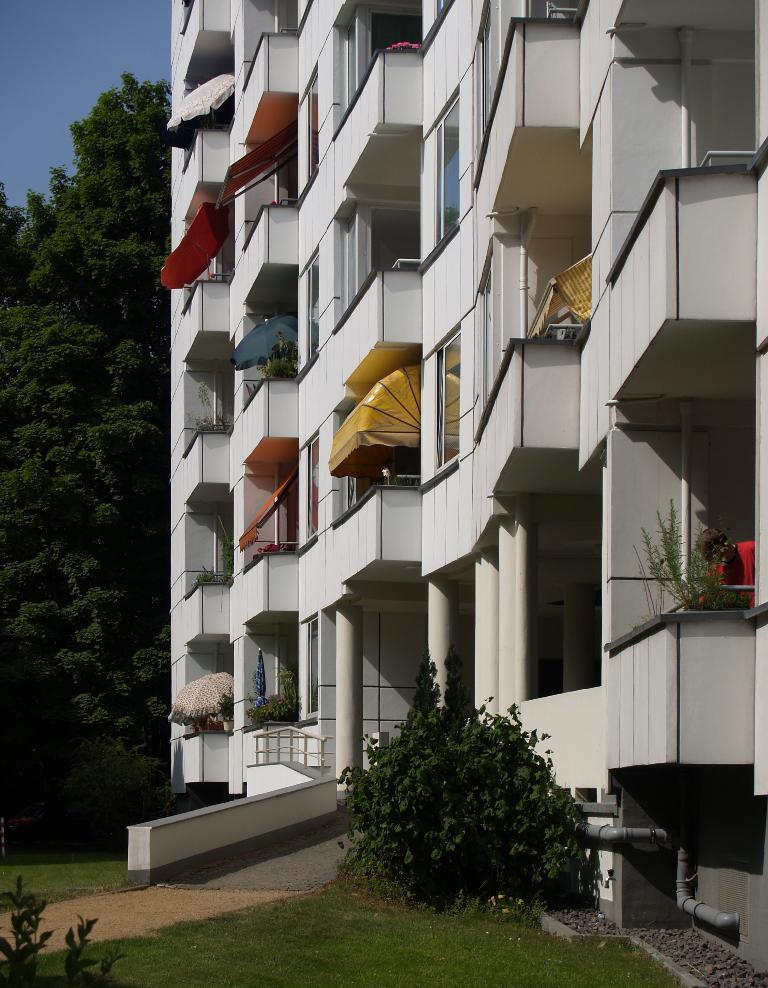In one or two sentences, can you explain what this image depicts? In this image there is a building, pillars, railing, plants, grass, tree, sky and objects.   